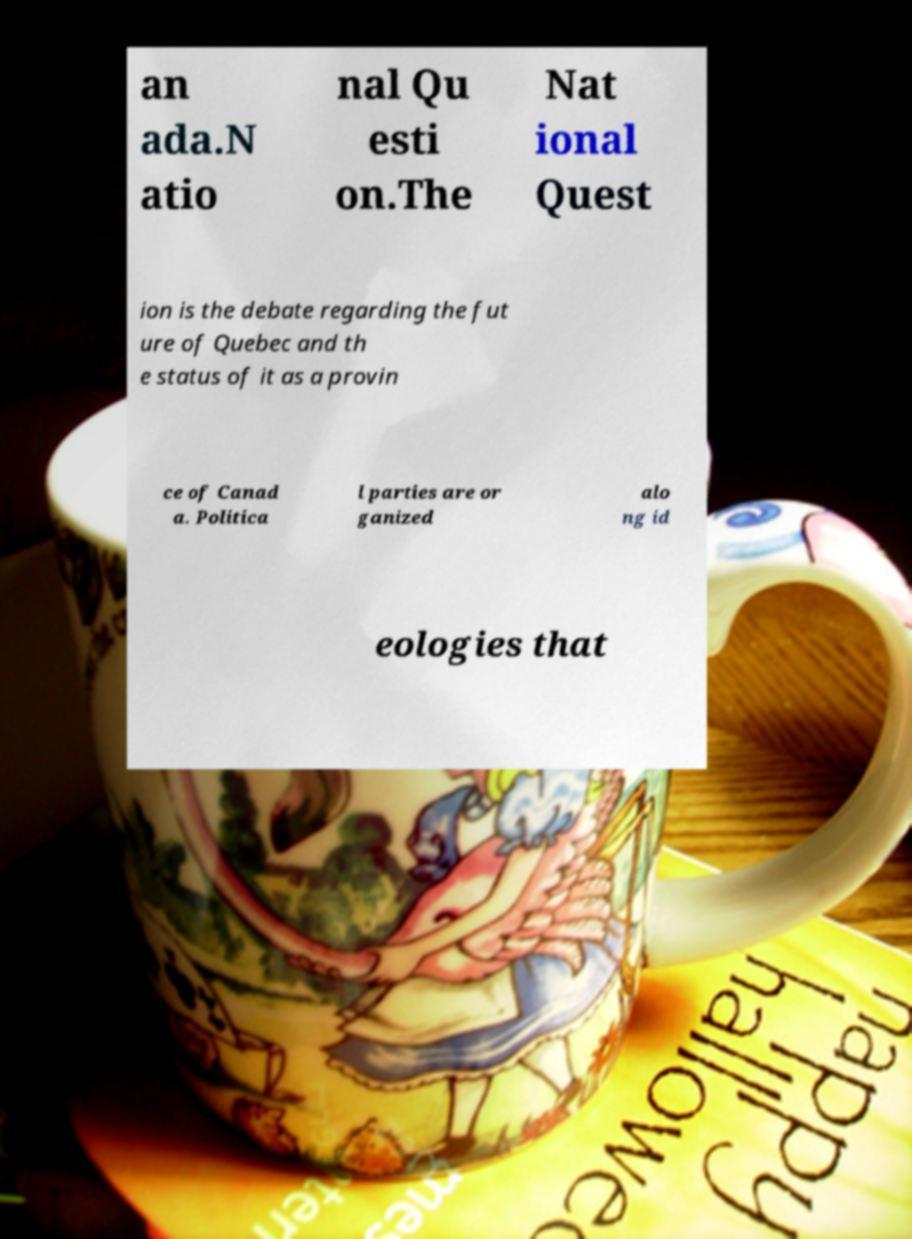Could you extract and type out the text from this image? an ada.N atio nal Qu esti on.The Nat ional Quest ion is the debate regarding the fut ure of Quebec and th e status of it as a provin ce of Canad a. Politica l parties are or ganized alo ng id eologies that 